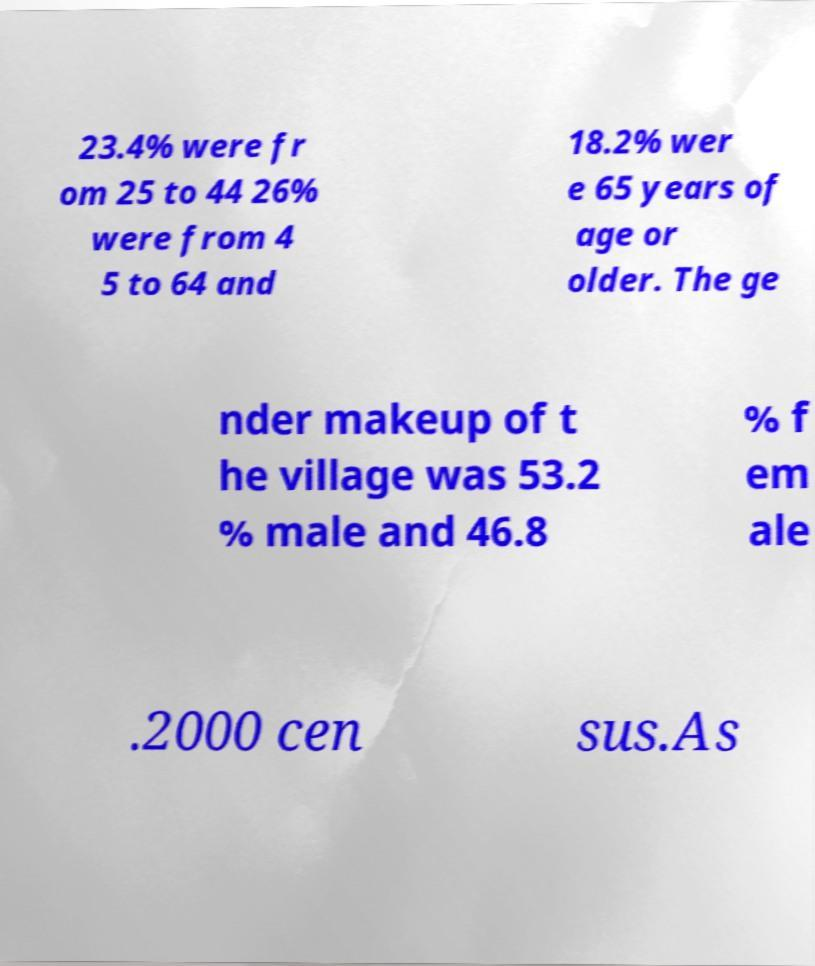Could you extract and type out the text from this image? 23.4% were fr om 25 to 44 26% were from 4 5 to 64 and 18.2% wer e 65 years of age or older. The ge nder makeup of t he village was 53.2 % male and 46.8 % f em ale .2000 cen sus.As 